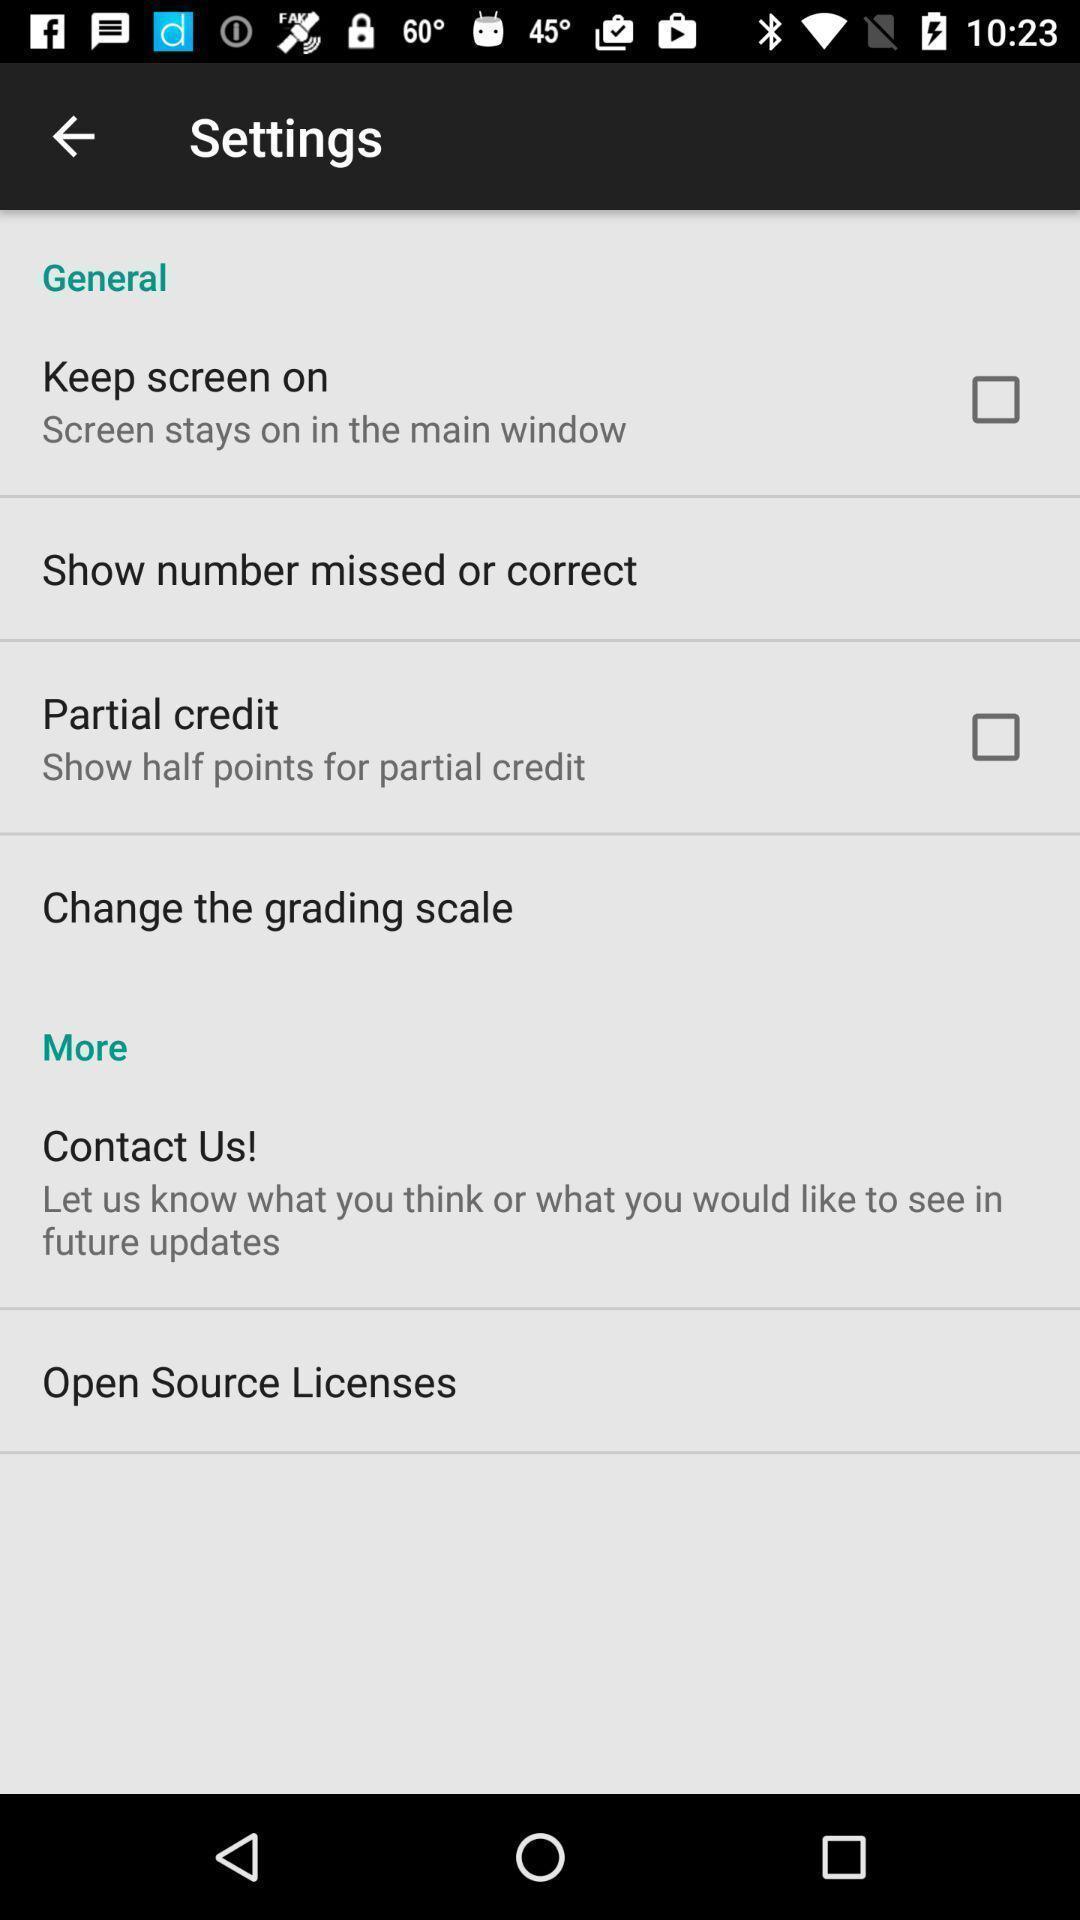Give me a narrative description of this picture. Settings page. 